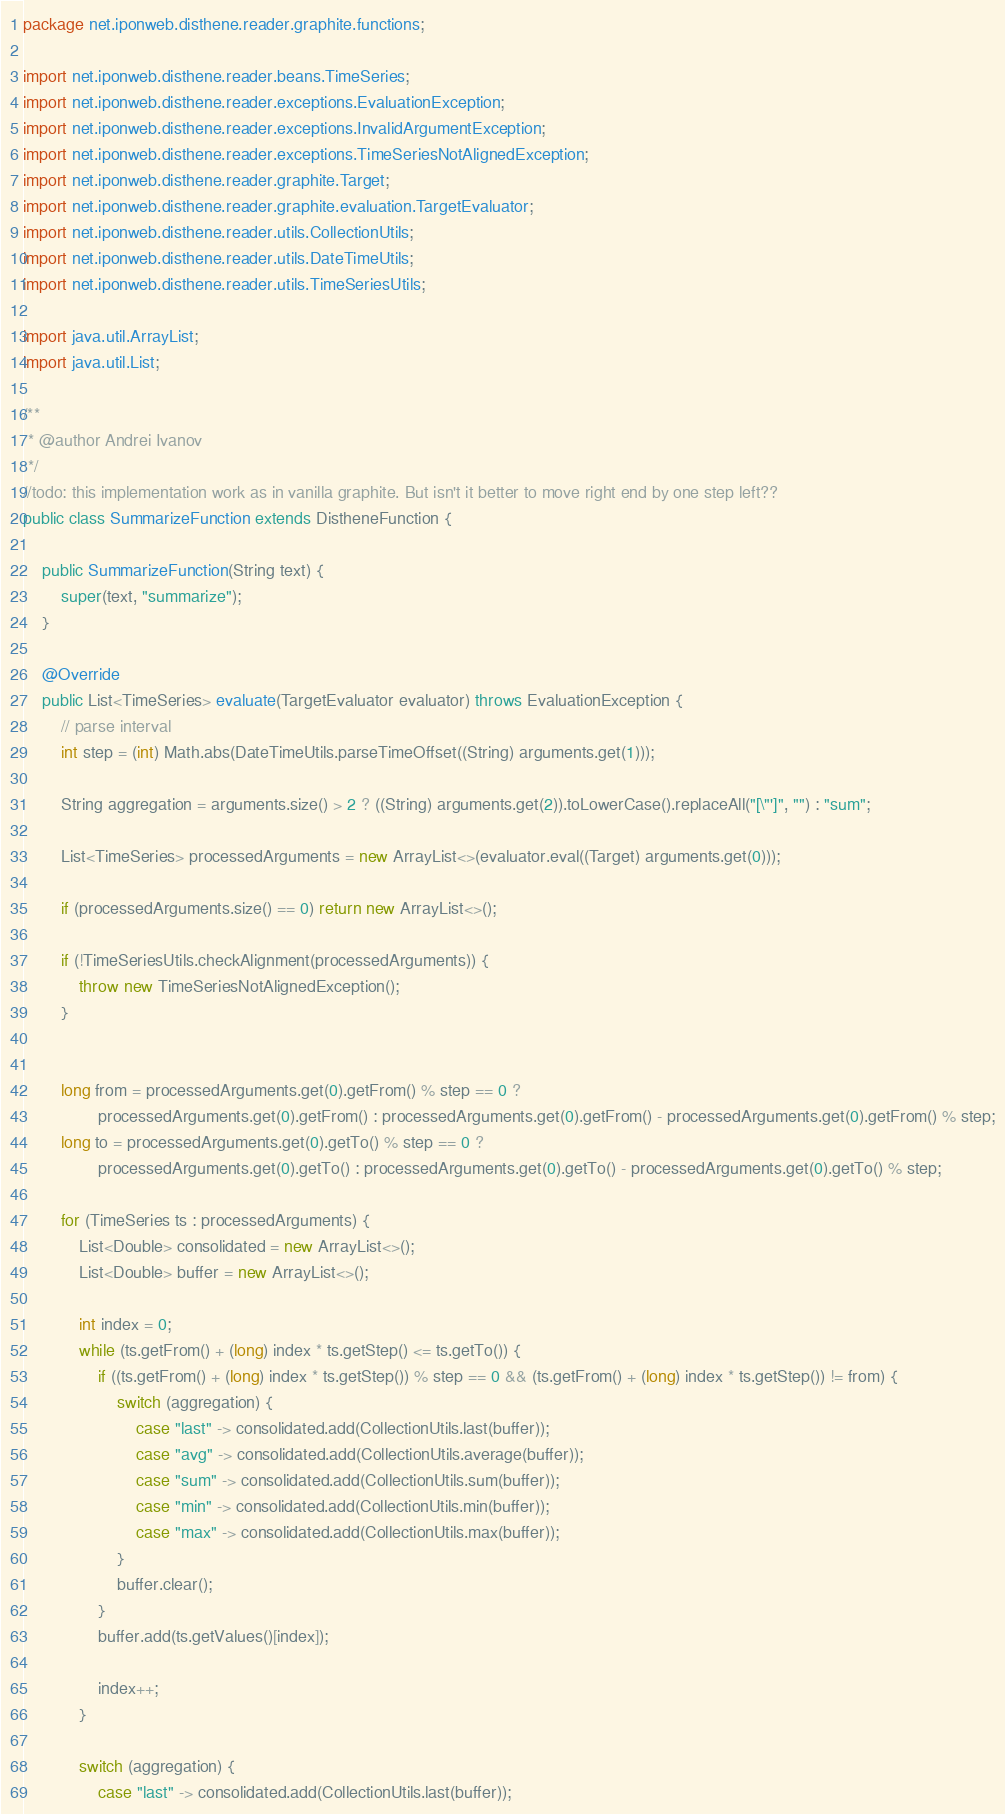<code> <loc_0><loc_0><loc_500><loc_500><_Java_>package net.iponweb.disthene.reader.graphite.functions;

import net.iponweb.disthene.reader.beans.TimeSeries;
import net.iponweb.disthene.reader.exceptions.EvaluationException;
import net.iponweb.disthene.reader.exceptions.InvalidArgumentException;
import net.iponweb.disthene.reader.exceptions.TimeSeriesNotAlignedException;
import net.iponweb.disthene.reader.graphite.Target;
import net.iponweb.disthene.reader.graphite.evaluation.TargetEvaluator;
import net.iponweb.disthene.reader.utils.CollectionUtils;
import net.iponweb.disthene.reader.utils.DateTimeUtils;
import net.iponweb.disthene.reader.utils.TimeSeriesUtils;

import java.util.ArrayList;
import java.util.List;

/**
 * @author Andrei Ivanov
 */
//todo: this implementation work as in vanilla graphite. But isn't it better to move right end by one step left??
public class SummarizeFunction extends DistheneFunction {

    public SummarizeFunction(String text) {
        super(text, "summarize");
    }

    @Override
    public List<TimeSeries> evaluate(TargetEvaluator evaluator) throws EvaluationException {
        // parse interval
        int step = (int) Math.abs(DateTimeUtils.parseTimeOffset((String) arguments.get(1)));

        String aggregation = arguments.size() > 2 ? ((String) arguments.get(2)).toLowerCase().replaceAll("[\"']", "") : "sum";

        List<TimeSeries> processedArguments = new ArrayList<>(evaluator.eval((Target) arguments.get(0)));

        if (processedArguments.size() == 0) return new ArrayList<>();

        if (!TimeSeriesUtils.checkAlignment(processedArguments)) {
            throw new TimeSeriesNotAlignedException();
        }


        long from = processedArguments.get(0).getFrom() % step == 0 ?
                processedArguments.get(0).getFrom() : processedArguments.get(0).getFrom() - processedArguments.get(0).getFrom() % step;
        long to = processedArguments.get(0).getTo() % step == 0 ?
                processedArguments.get(0).getTo() : processedArguments.get(0).getTo() - processedArguments.get(0).getTo() % step;

        for (TimeSeries ts : processedArguments) {
            List<Double> consolidated = new ArrayList<>();
            List<Double> buffer = new ArrayList<>();

            int index = 0;
            while (ts.getFrom() + (long) index * ts.getStep() <= ts.getTo()) {
                if ((ts.getFrom() + (long) index * ts.getStep()) % step == 0 && (ts.getFrom() + (long) index * ts.getStep()) != from) {
                    switch (aggregation) {
                        case "last" -> consolidated.add(CollectionUtils.last(buffer));
                        case "avg" -> consolidated.add(CollectionUtils.average(buffer));
                        case "sum" -> consolidated.add(CollectionUtils.sum(buffer));
                        case "min" -> consolidated.add(CollectionUtils.min(buffer));
                        case "max" -> consolidated.add(CollectionUtils.max(buffer));
                    }
                    buffer.clear();
                }
                buffer.add(ts.getValues()[index]);

                index++;
            }

            switch (aggregation) {
                case "last" -> consolidated.add(CollectionUtils.last(buffer));</code> 